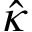Convert formula to latex. <formula><loc_0><loc_0><loc_500><loc_500>\hat { \kappa }</formula> 